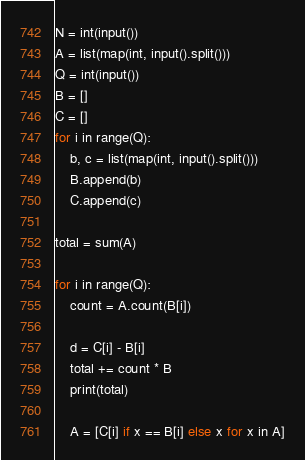<code> <loc_0><loc_0><loc_500><loc_500><_Python_>N = int(input())
A = list(map(int, input().split()))
Q = int(input())
B = []
C = []
for i in range(Q):
    b, c = list(map(int, input().split()))
    B.append(b)
    C.append(c)

total = sum(A)

for i in range(Q):
    count = A.count(B[i])

    d = C[i] - B[i]
    total += count * B
    print(total)

    A = [C[i] if x == B[i] else x for x in A]
</code> 